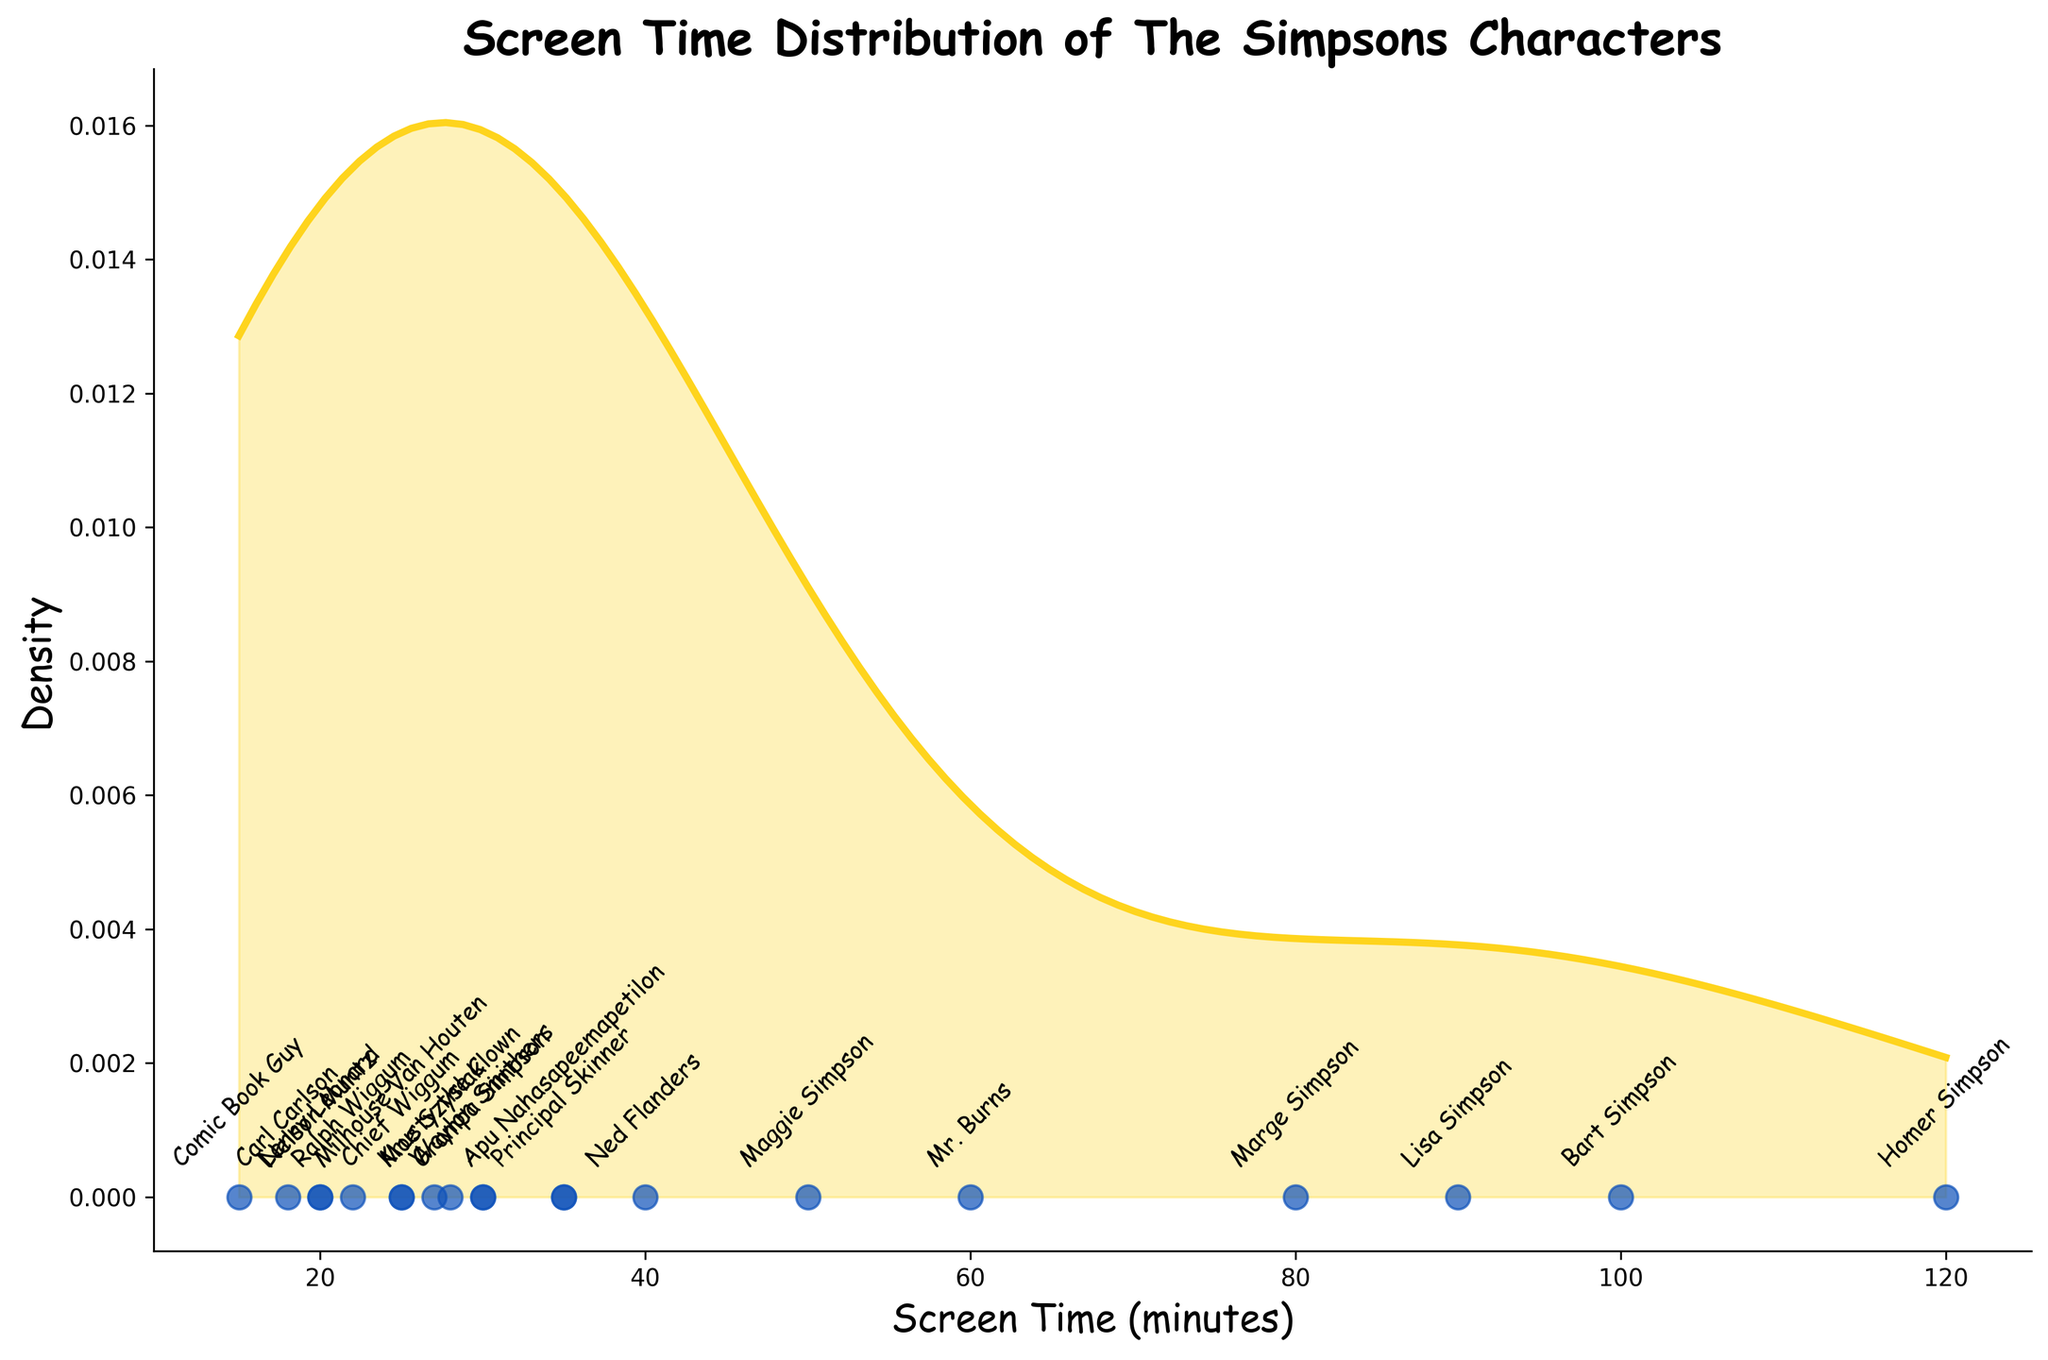What is the title of the plot? The title is generally located at the top of the plot and clearly signifies what the visualization is about.
Answer: Screen Time Distribution of The Simpsons Characters Which Simpson character has the highest screen time? By looking at the annotated data points, find the character corresponding to the highest screen time value.
Answer: Homer Simpson Which character has a screen time of 27 minutes? Check the annotations along the x-axis for the screen time of 27 minutes.
Answer: Moe Szyslak How many characters have a screen time of 35 minutes? Identify and count the annotations at the screen time value of 35 minutes.
Answer: 2 (Apu Nahasapeemapetilon and Principal Skinner) What is the screen time range presented in the plot? Find the minimum and maximum values on the x-axis.
Answer: 15 to 120 minutes What is the color of the density curve? Identify the color used to draw the density curve in the plot.
Answer: Yellow What information does the y-axis represent in this plot? Refer to the y-axis label for its denotation in the density plot context.
Answer: Density Which character has less screen time, Carl Carlson or Nelson Muntz? Compare the screen time annotations for Carl Carlson and Nelson Muntz.
Answer: Carl Carlson How does the density value change as the screen time increases? Observing the shape of the density curve, describe the density trend as screen time values increase.
Answer: Initially increases, peaks around 40-60 minutes, then decreases What is the noticeable peak in the density curve corresponding to? Identify the screen time range where the density curve has a noticeable peak.
Answer: Around 40 to 60 minutes 